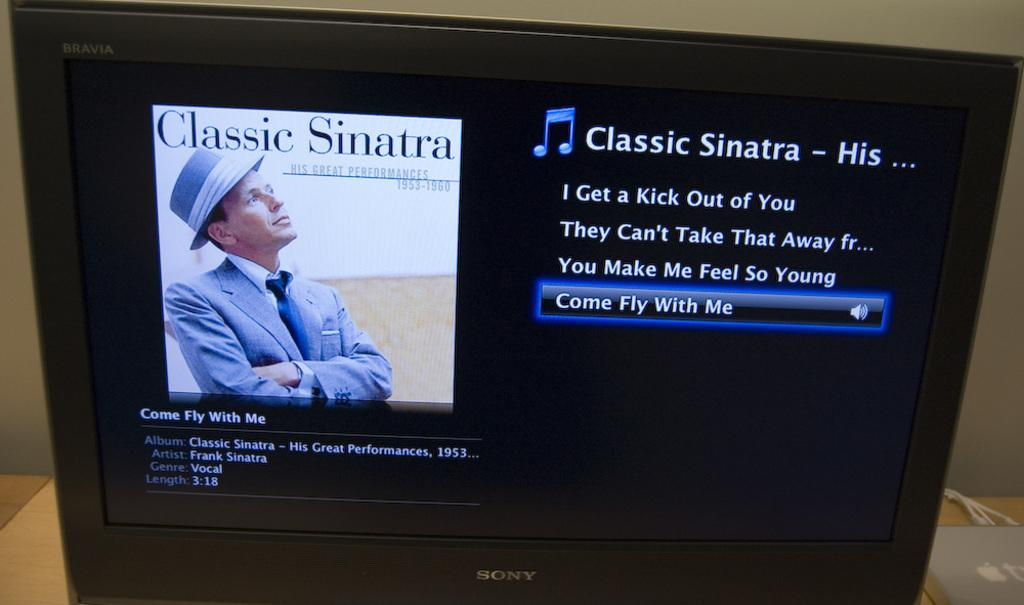Provide a one-sentence caption for the provided image. Video monitor that has music titled Classic Sinatra featuring four songs. 